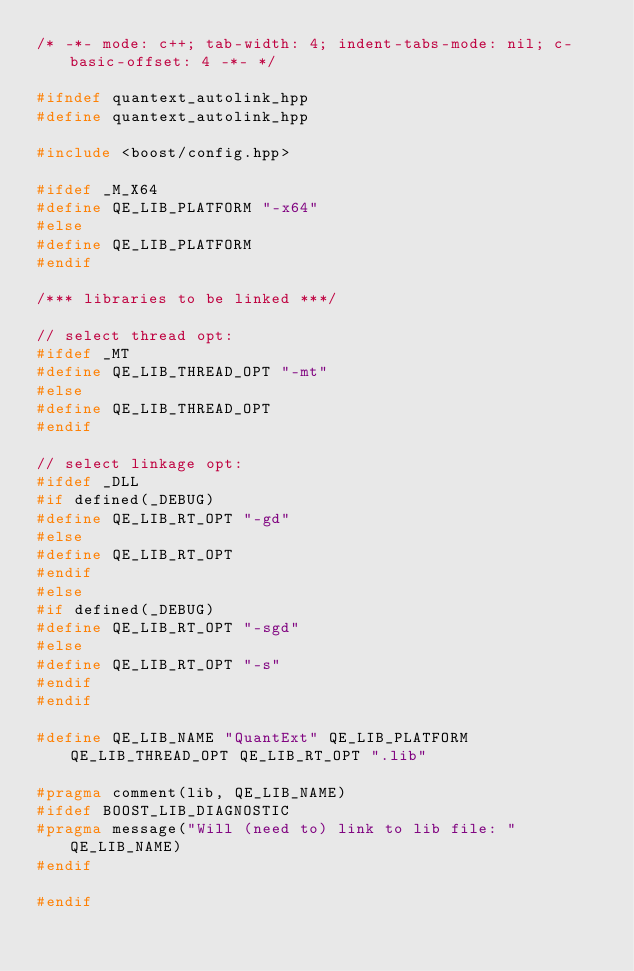Convert code to text. <code><loc_0><loc_0><loc_500><loc_500><_C++_>/* -*- mode: c++; tab-width: 4; indent-tabs-mode: nil; c-basic-offset: 4 -*- */

#ifndef quantext_autolink_hpp
#define quantext_autolink_hpp

#include <boost/config.hpp>

#ifdef _M_X64
#define QE_LIB_PLATFORM "-x64"
#else
#define QE_LIB_PLATFORM
#endif

/*** libraries to be linked ***/

// select thread opt:
#ifdef _MT
#define QE_LIB_THREAD_OPT "-mt"
#else
#define QE_LIB_THREAD_OPT
#endif

// select linkage opt:
#ifdef _DLL
#if defined(_DEBUG)
#define QE_LIB_RT_OPT "-gd"
#else
#define QE_LIB_RT_OPT
#endif
#else
#if defined(_DEBUG)
#define QE_LIB_RT_OPT "-sgd"
#else
#define QE_LIB_RT_OPT "-s"
#endif
#endif

#define QE_LIB_NAME "QuantExt" QE_LIB_PLATFORM QE_LIB_THREAD_OPT QE_LIB_RT_OPT ".lib"

#pragma comment(lib, QE_LIB_NAME)
#ifdef BOOST_LIB_DIAGNOSTIC
#pragma message("Will (need to) link to lib file: " QE_LIB_NAME)
#endif

#endif
</code> 